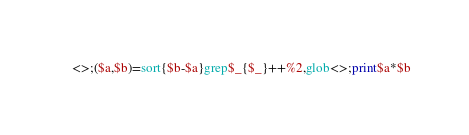<code> <loc_0><loc_0><loc_500><loc_500><_Perl_><>;($a,$b)=sort{$b-$a}grep$_{$_}++%2,glob<>;print$a*$b</code> 